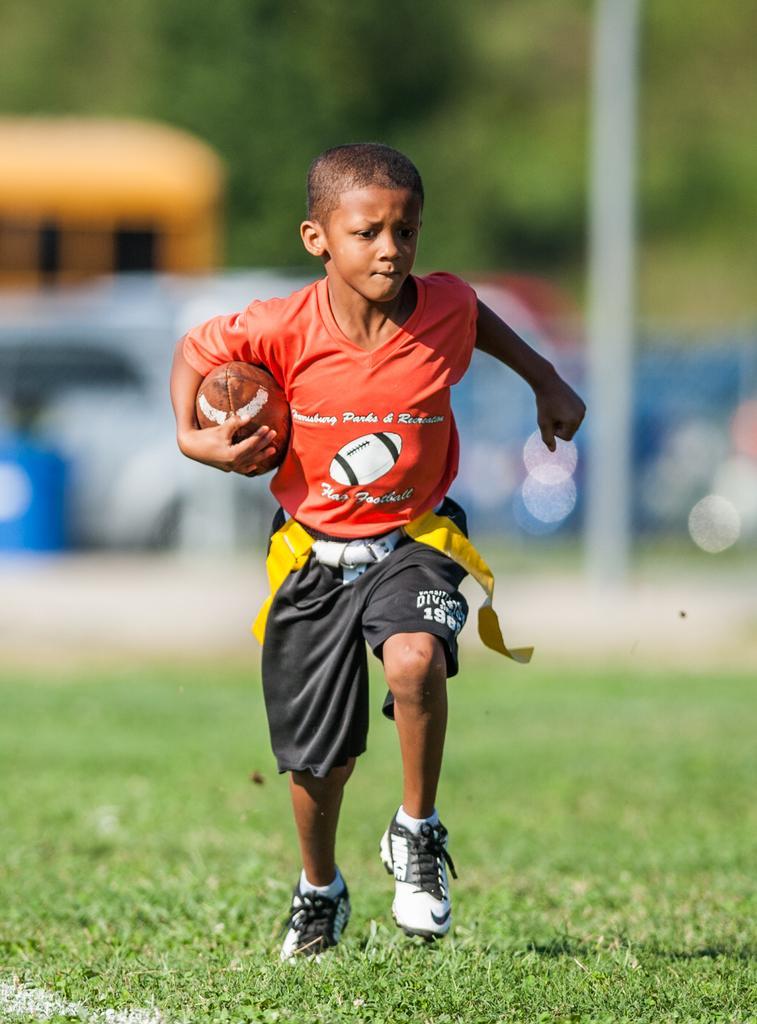Describe this image in one or two sentences. A boy is running on a field hold a rugby ball. He wears a orange T shirt and black color shorts with a white shoes. 